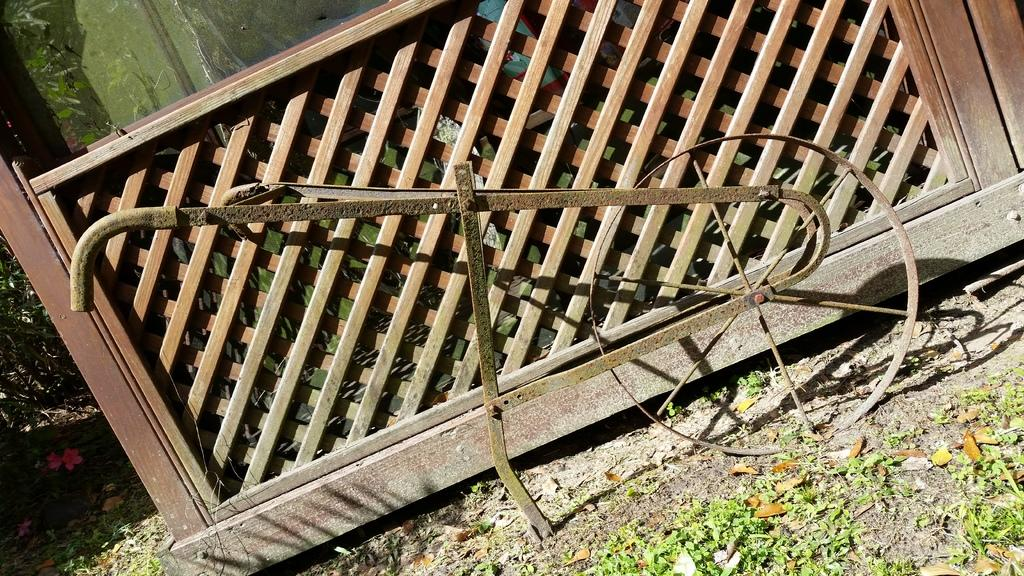What type of object can be seen on the path in the image? There is an iron object and a wooden object on the path in the image. What is located behind the wooden object? There is a glass and plants behind the wooden object. What can be found on the ground in the image? There are dry leaves on the path. How much money is being weighed on the iron object in the image? There is no money or any indication of weighing in the image; it only shows an iron object, a wooden object, and other elements mentioned in the facts. 